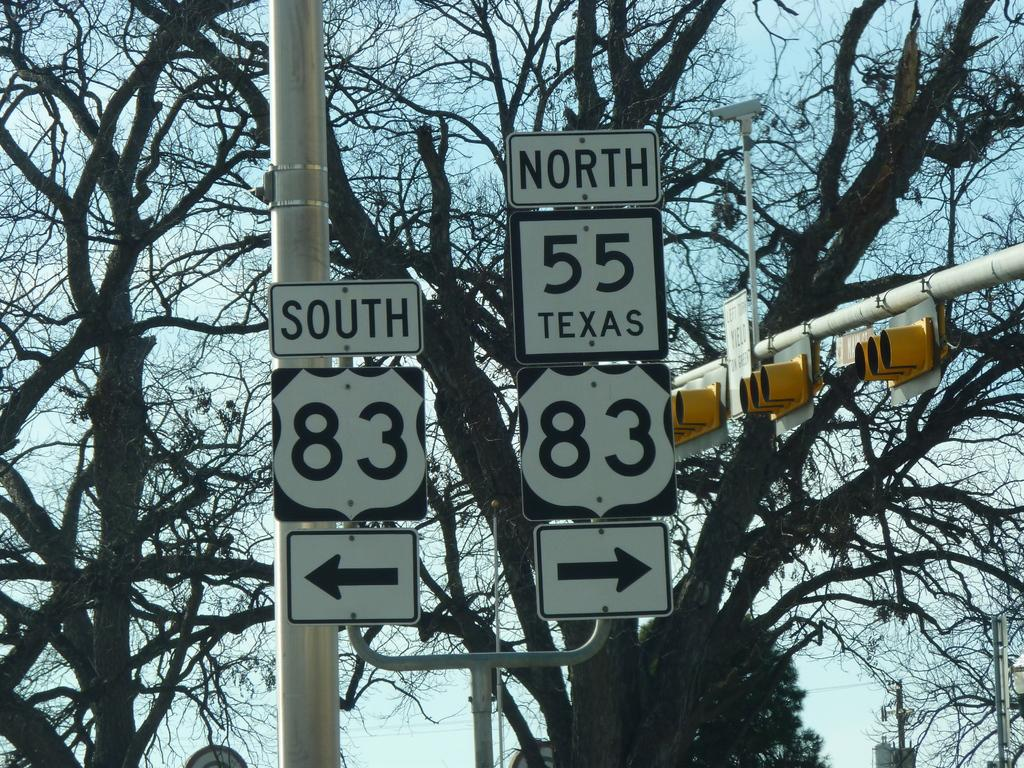What objects are present in the image that provide information or guidance? There are sign boards in the image. What objects in the image help control traffic flow? There are signal lights in the image. What type of natural elements can be seen in the background of the image? There are trees in the background of the image. What part of the natural environment is visible in the background of the image? The sky is visible in the background of the image. What type of soda is being advertised on the sign boards in the image? There is no soda being advertised on the sign boards in the image; the sign boards provide information or guidance related to traffic or directions. 